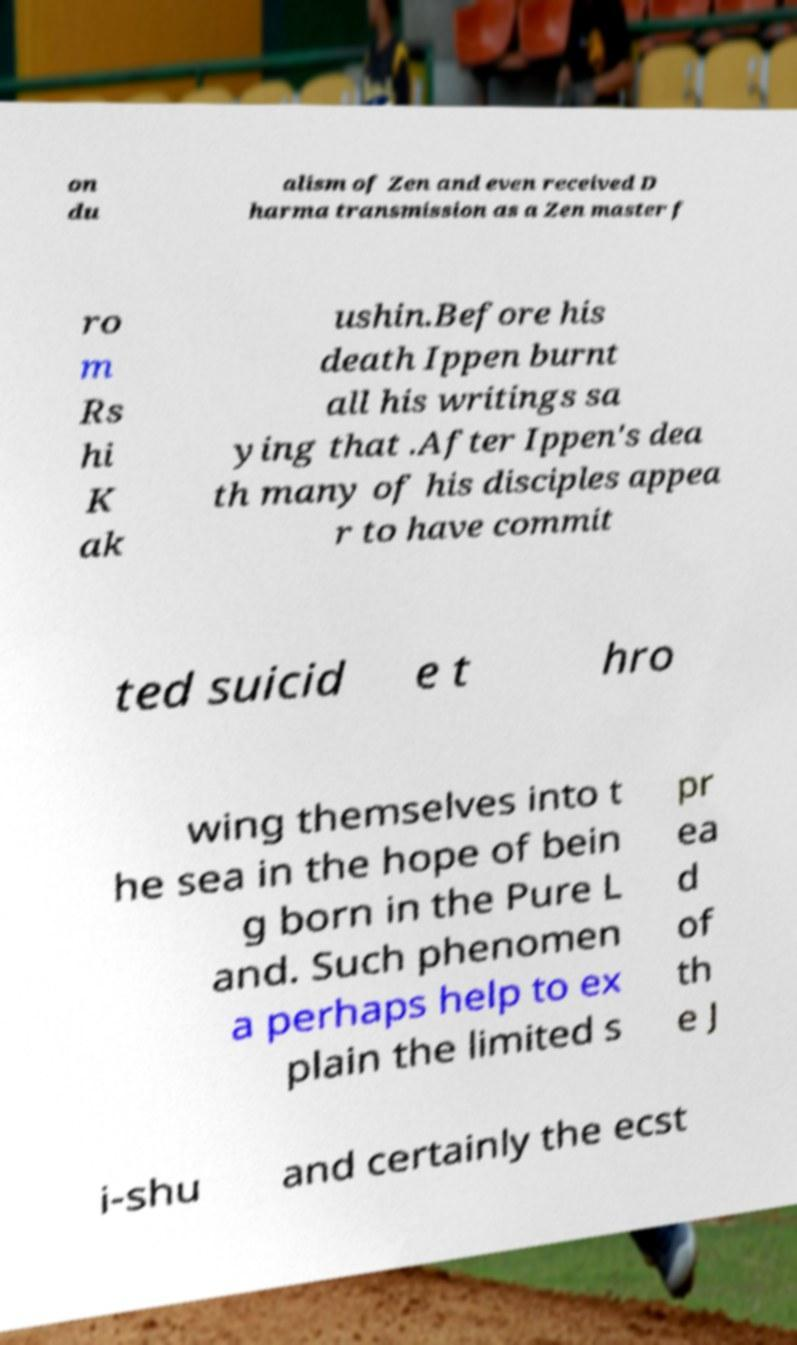What messages or text are displayed in this image? I need them in a readable, typed format. on du alism of Zen and even received D harma transmission as a Zen master f ro m Rs hi K ak ushin.Before his death Ippen burnt all his writings sa ying that .After Ippen's dea th many of his disciples appea r to have commit ted suicid e t hro wing themselves into t he sea in the hope of bein g born in the Pure L and. Such phenomen a perhaps help to ex plain the limited s pr ea d of th e J i-shu and certainly the ecst 